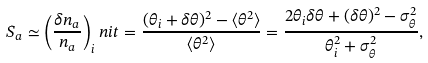<formula> <loc_0><loc_0><loc_500><loc_500>S _ { a } \simeq \left ( \frac { \delta n _ { a } } { n _ { a } } \right ) _ { i } n i t = \frac { ( \theta _ { i } + \delta \theta ) ^ { 2 } - \langle \theta ^ { 2 } \rangle } { \langle \theta ^ { 2 } \rangle } = \frac { 2 \theta _ { i } \delta \theta + ( \delta \theta ) ^ { 2 } - \sigma _ { \theta } ^ { 2 } } { \theta _ { i } ^ { 2 } + \sigma _ { \theta } ^ { 2 } } ,</formula> 